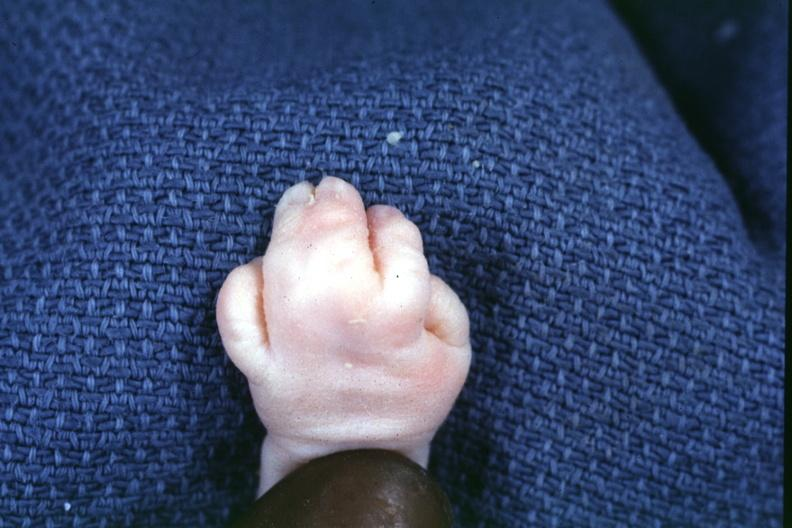s syndactyly present?
Answer the question using a single word or phrase. Yes 